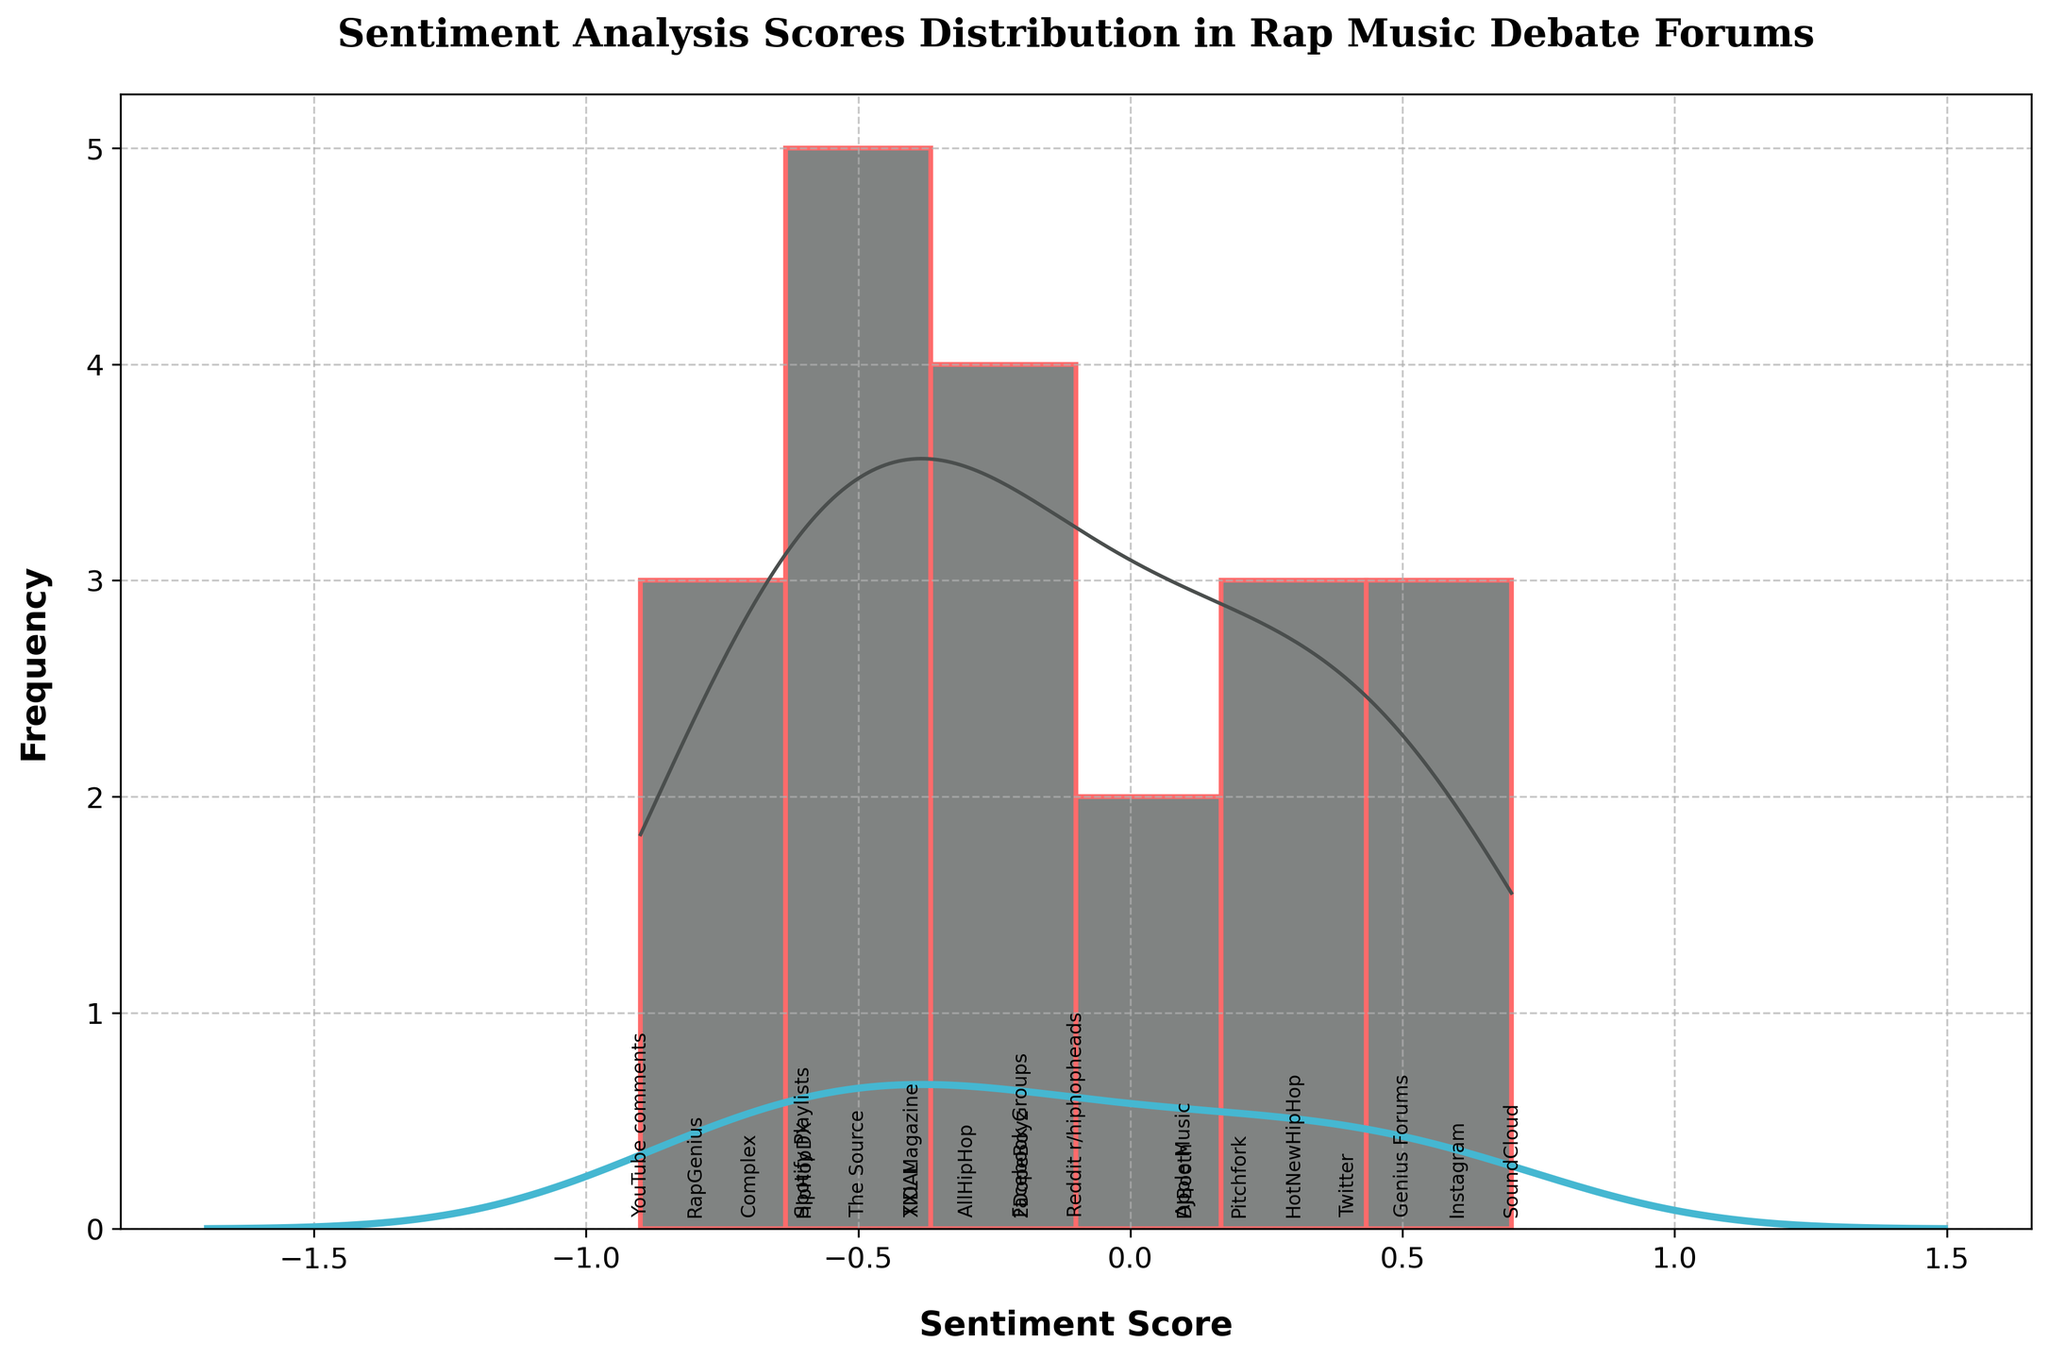what is the overall sentiment distribution in the figure? The histogram shows sentiment scores for online comments in rap music debate forums. The bars' height represents frequency, and the KDE curve shows the probability density. Both reveal that sentiment scores are skewed slightly negative, with more instances around -0.6 to 0.0 and fewer around 0.5 to 0.7.
Answer: Slightly negative skew what's the title of the plot? The plot's title is given at the top of the figure
Answer: Sentiment Analysis Scores Distribution in Rap Music Debate Forums which sentiment score has the highest frequency? The histogram shows the height of bars at each sentiment score. The tallest bar is at sentiment score -0.2
Answer: -0.2 how many online comment sources are labeled on the x-axis? The x-axis labels each sentiment score with its source. Count these labels
Answer: 20 compare the frequency of positive versus negative sentiment scores Positive sentiment scores (above 0) have shorter histogram bars than negative scores (below 0), indicating higher negative frequency
Answer: Higher negative frequency which sentiment score has the least density, according to the KDE curve? The KDE curve dips to its lowest point at sentiment score 0.7
Answer: 0.7 what is the sentiment score range covered in the plot? The x-axis extends from the lowest to the highest sentiment score, which is -0.9 to 0.7
Answer: -0.9 to 0.7 identify the comment source with the most positive sentiment score The most positive sentiment score is 0.7, and the x-axis label for this score is SoundCloud
Answer: SoundCloud find the average of the two most negative sentiment scores The two most negative sentiment scores are -0.9 and -0.8. Their average is (-0.9 + -0.8) / 2 = -0.85
Answer: -0.85 which sentiment score and source appear at zero on the x-axis? The annotation at zero on the x-axis marks the sentiment score -0.3 and source AllHipHop
Answer: -0.3, AllHipHop 